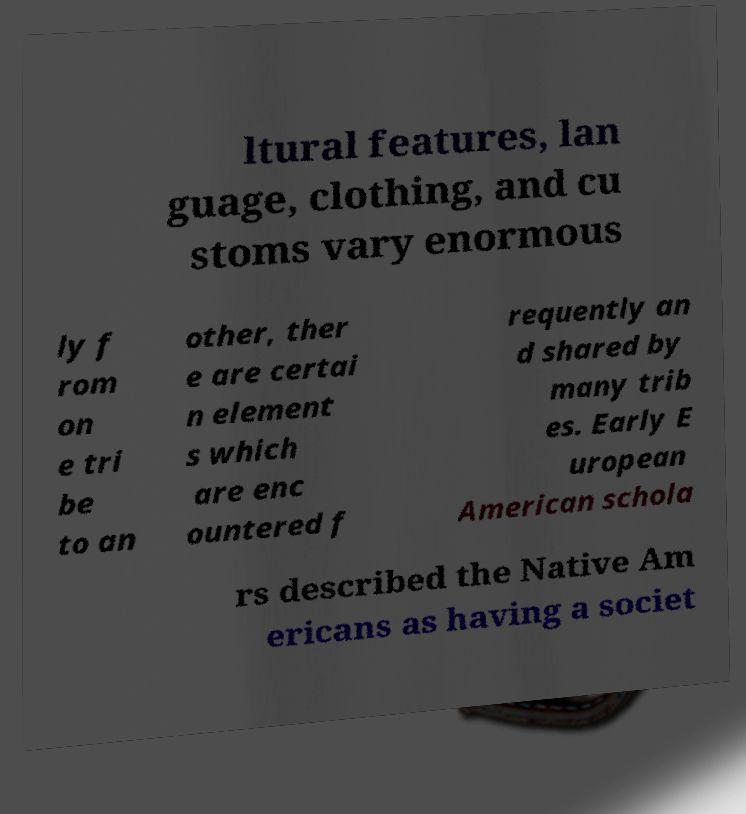Could you assist in decoding the text presented in this image and type it out clearly? ltural features, lan guage, clothing, and cu stoms vary enormous ly f rom on e tri be to an other, ther e are certai n element s which are enc ountered f requently an d shared by many trib es. Early E uropean American schola rs described the Native Am ericans as having a societ 